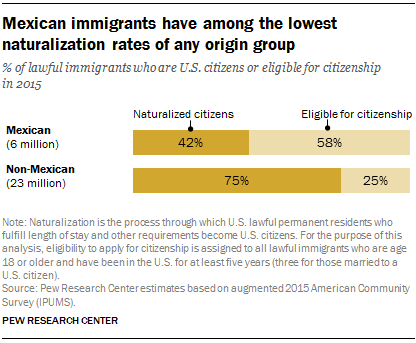Indicate a few pertinent items in this graphic. The number of Mexican immigrants eligible for citizenship is approximately 0.58. According to the provided data, 83% of eligible citizens in Mexico and non-Mexicans are eligible for the program. 